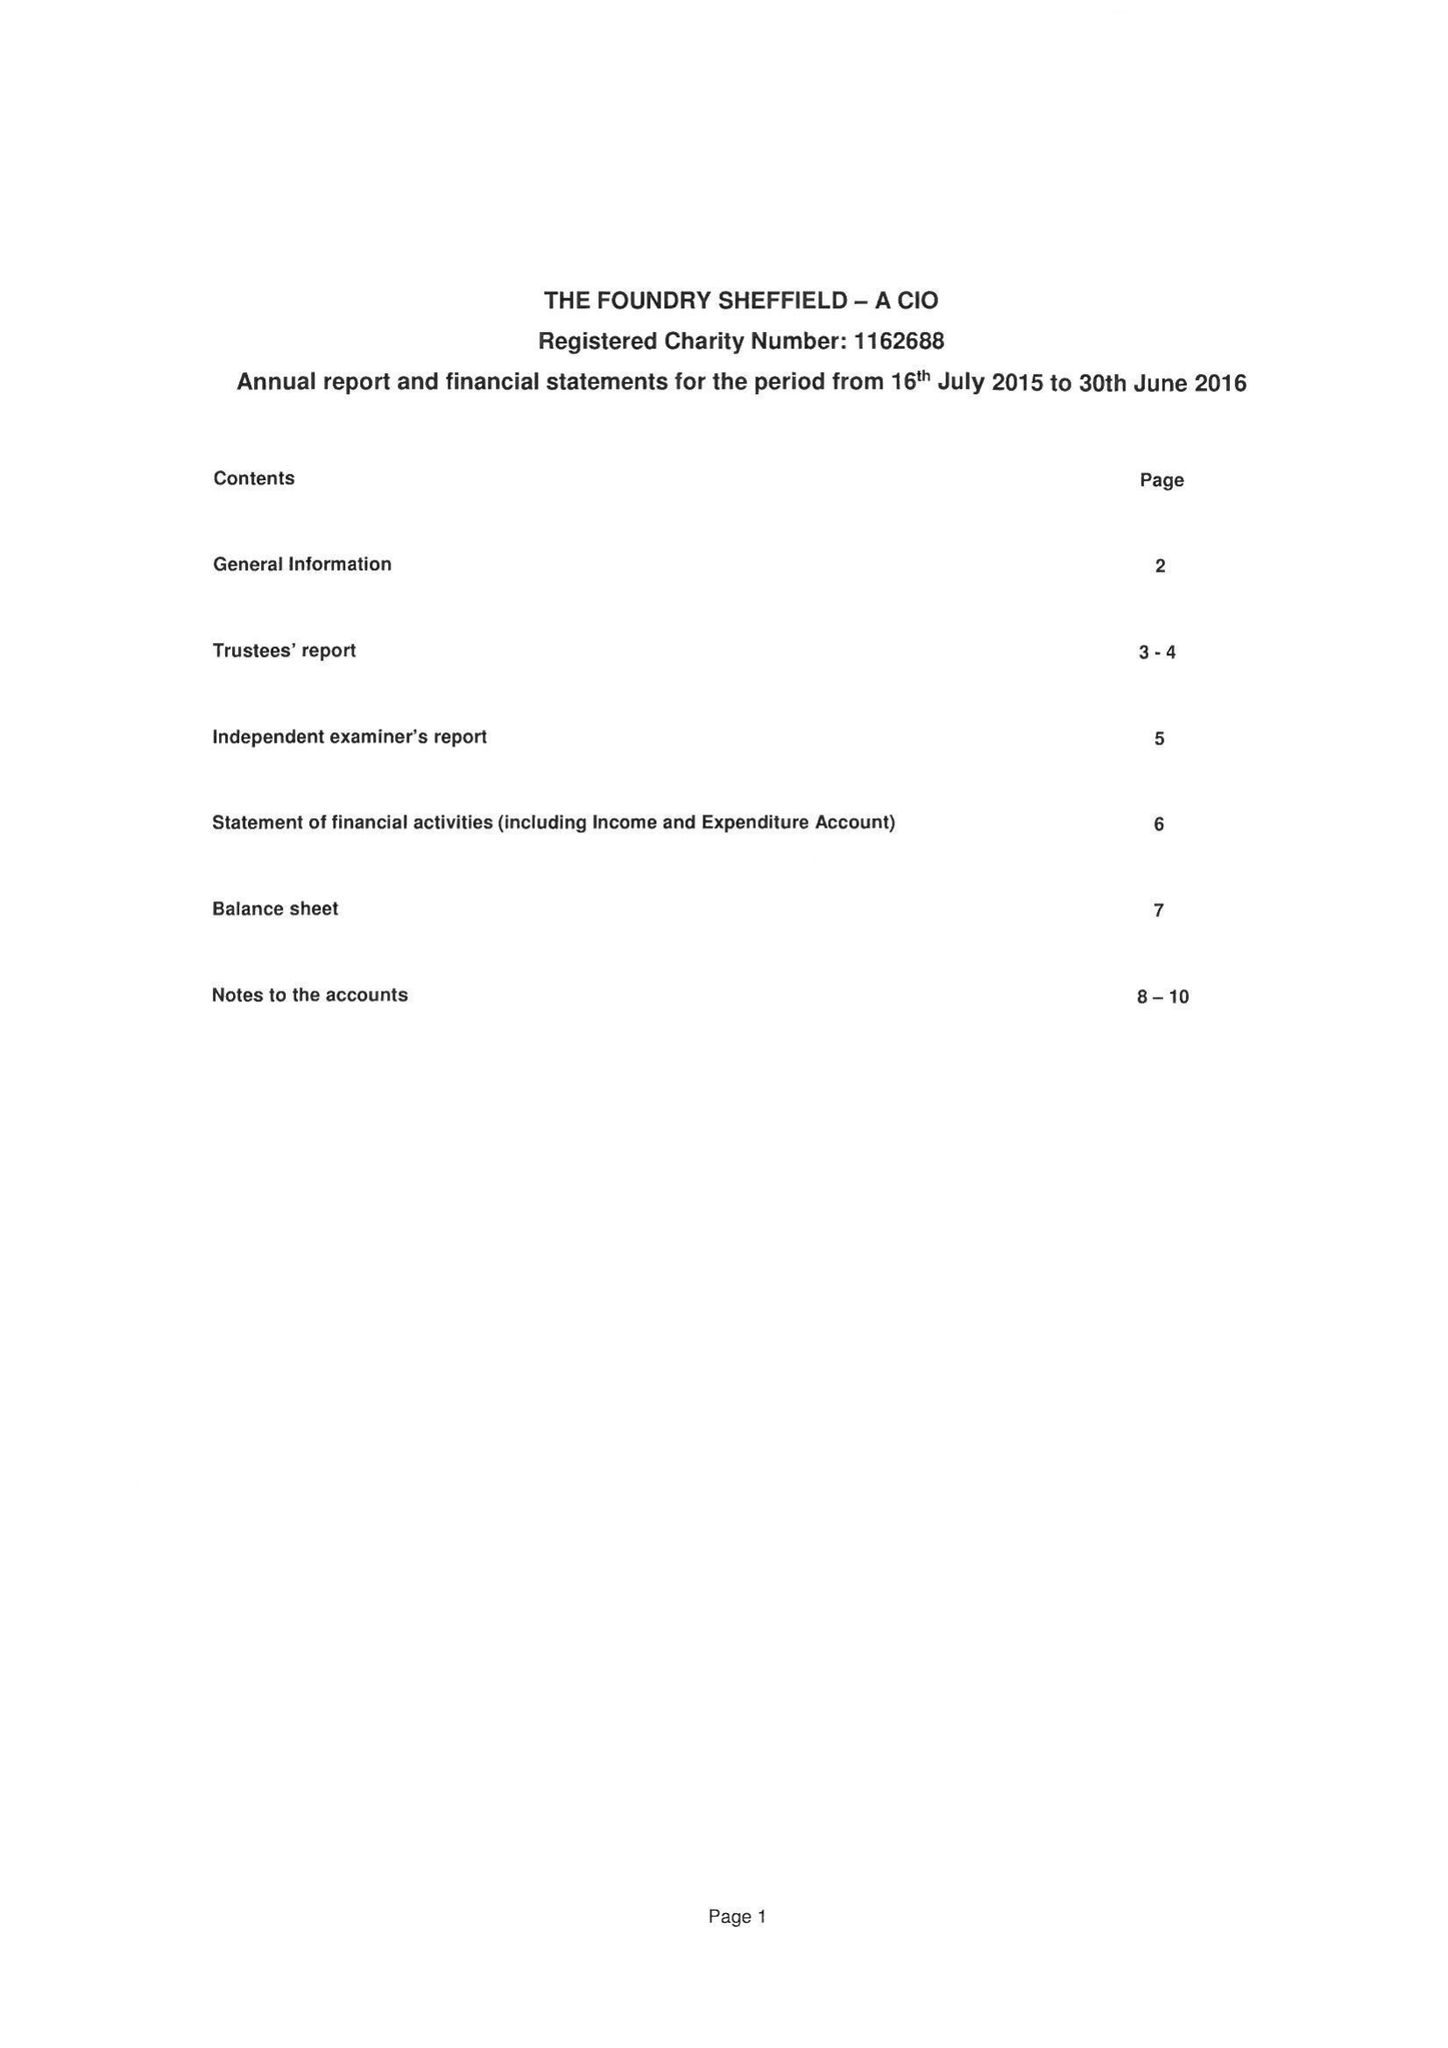What is the value for the charity_name?
Answer the question using a single word or phrase. The Foundry Sheffield 